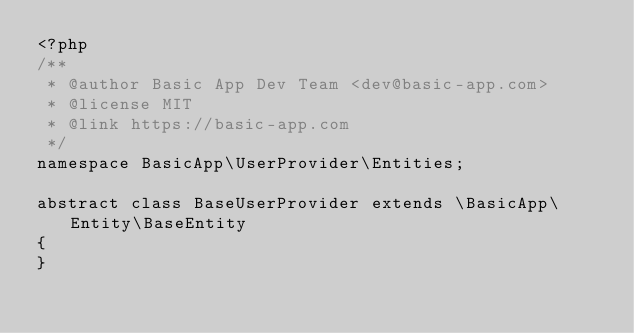<code> <loc_0><loc_0><loc_500><loc_500><_PHP_><?php
/**
 * @author Basic App Dev Team <dev@basic-app.com>
 * @license MIT
 * @link https://basic-app.com
 */
namespace BasicApp\UserProvider\Entities;

abstract class BaseUserProvider extends \BasicApp\Entity\BaseEntity
{
}</code> 